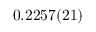<formula> <loc_0><loc_0><loc_500><loc_500>0 . 2 2 5 7 ( 2 1 )</formula> 